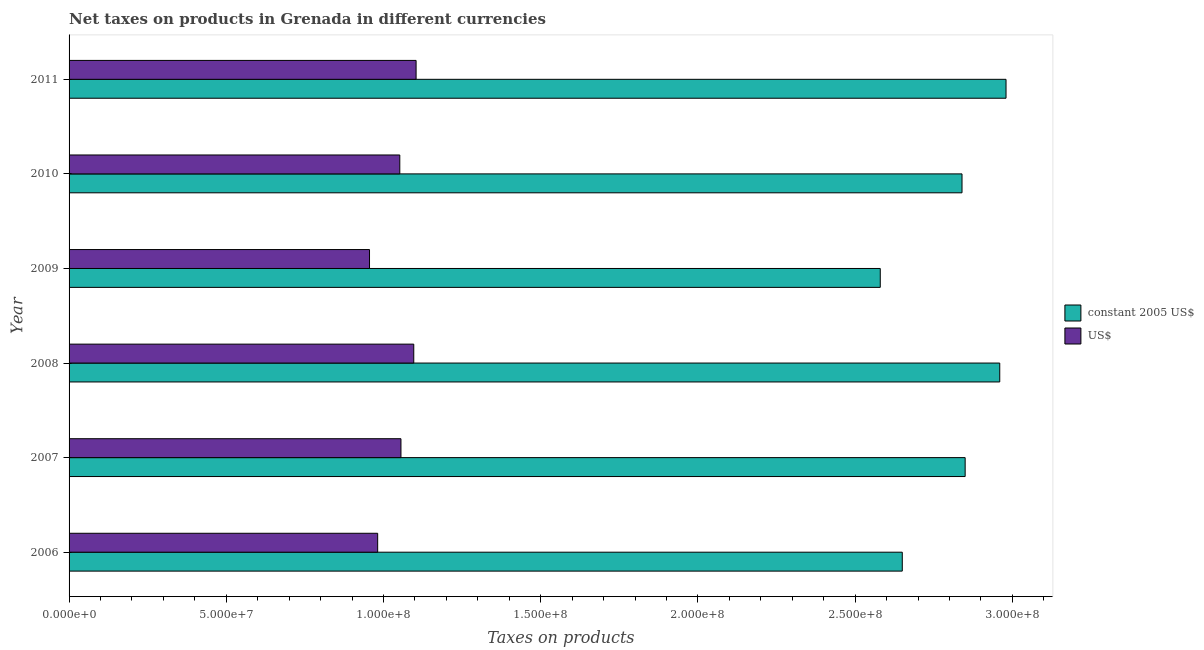How many groups of bars are there?
Provide a succinct answer. 6. Are the number of bars per tick equal to the number of legend labels?
Your answer should be very brief. Yes. How many bars are there on the 2nd tick from the bottom?
Keep it short and to the point. 2. What is the label of the 6th group of bars from the top?
Your response must be concise. 2006. In how many cases, is the number of bars for a given year not equal to the number of legend labels?
Provide a succinct answer. 0. What is the net taxes in constant 2005 us$ in 2009?
Your answer should be very brief. 2.58e+08. Across all years, what is the maximum net taxes in constant 2005 us$?
Offer a very short reply. 2.98e+08. Across all years, what is the minimum net taxes in us$?
Provide a short and direct response. 9.56e+07. In which year was the net taxes in constant 2005 us$ maximum?
Keep it short and to the point. 2011. In which year was the net taxes in constant 2005 us$ minimum?
Provide a short and direct response. 2009. What is the total net taxes in constant 2005 us$ in the graph?
Provide a short and direct response. 1.69e+09. What is the difference between the net taxes in us$ in 2006 and that in 2010?
Provide a succinct answer. -7.04e+06. What is the difference between the net taxes in us$ in 2008 and the net taxes in constant 2005 us$ in 2006?
Offer a very short reply. -1.55e+08. What is the average net taxes in us$ per year?
Provide a succinct answer. 1.04e+08. In the year 2007, what is the difference between the net taxes in us$ and net taxes in constant 2005 us$?
Your response must be concise. -1.79e+08. In how many years, is the net taxes in constant 2005 us$ greater than 40000000 units?
Your answer should be compact. 6. Is the difference between the net taxes in constant 2005 us$ in 2009 and 2011 greater than the difference between the net taxes in us$ in 2009 and 2011?
Provide a succinct answer. No. What is the difference between the highest and the second highest net taxes in us$?
Your answer should be very brief. 7.41e+05. What is the difference between the highest and the lowest net taxes in constant 2005 us$?
Ensure brevity in your answer.  4.00e+07. Is the sum of the net taxes in constant 2005 us$ in 2007 and 2009 greater than the maximum net taxes in us$ across all years?
Your answer should be very brief. Yes. What does the 1st bar from the top in 2011 represents?
Give a very brief answer. US$. What does the 2nd bar from the bottom in 2009 represents?
Provide a short and direct response. US$. How many bars are there?
Provide a short and direct response. 12. Are all the bars in the graph horizontal?
Give a very brief answer. Yes. How many years are there in the graph?
Your answer should be compact. 6. Are the values on the major ticks of X-axis written in scientific E-notation?
Offer a very short reply. Yes. Does the graph contain grids?
Your answer should be compact. No. Where does the legend appear in the graph?
Keep it short and to the point. Center right. How many legend labels are there?
Provide a short and direct response. 2. How are the legend labels stacked?
Your response must be concise. Vertical. What is the title of the graph?
Give a very brief answer. Net taxes on products in Grenada in different currencies. What is the label or title of the X-axis?
Provide a short and direct response. Taxes on products. What is the label or title of the Y-axis?
Keep it short and to the point. Year. What is the Taxes on products of constant 2005 US$ in 2006?
Give a very brief answer. 2.65e+08. What is the Taxes on products of US$ in 2006?
Give a very brief answer. 9.81e+07. What is the Taxes on products in constant 2005 US$ in 2007?
Keep it short and to the point. 2.85e+08. What is the Taxes on products in US$ in 2007?
Keep it short and to the point. 1.06e+08. What is the Taxes on products of constant 2005 US$ in 2008?
Provide a short and direct response. 2.96e+08. What is the Taxes on products of US$ in 2008?
Your answer should be compact. 1.10e+08. What is the Taxes on products in constant 2005 US$ in 2009?
Offer a terse response. 2.58e+08. What is the Taxes on products of US$ in 2009?
Provide a succinct answer. 9.56e+07. What is the Taxes on products of constant 2005 US$ in 2010?
Provide a succinct answer. 2.84e+08. What is the Taxes on products in US$ in 2010?
Provide a succinct answer. 1.05e+08. What is the Taxes on products of constant 2005 US$ in 2011?
Your answer should be compact. 2.98e+08. What is the Taxes on products of US$ in 2011?
Ensure brevity in your answer.  1.10e+08. Across all years, what is the maximum Taxes on products in constant 2005 US$?
Your answer should be very brief. 2.98e+08. Across all years, what is the maximum Taxes on products in US$?
Provide a short and direct response. 1.10e+08. Across all years, what is the minimum Taxes on products in constant 2005 US$?
Offer a very short reply. 2.58e+08. Across all years, what is the minimum Taxes on products in US$?
Give a very brief answer. 9.56e+07. What is the total Taxes on products in constant 2005 US$ in the graph?
Your answer should be compact. 1.69e+09. What is the total Taxes on products of US$ in the graph?
Offer a very short reply. 6.24e+08. What is the difference between the Taxes on products in constant 2005 US$ in 2006 and that in 2007?
Your answer should be very brief. -2.00e+07. What is the difference between the Taxes on products of US$ in 2006 and that in 2007?
Provide a succinct answer. -7.41e+06. What is the difference between the Taxes on products in constant 2005 US$ in 2006 and that in 2008?
Ensure brevity in your answer.  -3.10e+07. What is the difference between the Taxes on products in US$ in 2006 and that in 2008?
Your answer should be very brief. -1.15e+07. What is the difference between the Taxes on products of US$ in 2006 and that in 2009?
Your answer should be very brief. 2.59e+06. What is the difference between the Taxes on products of constant 2005 US$ in 2006 and that in 2010?
Your answer should be very brief. -1.90e+07. What is the difference between the Taxes on products of US$ in 2006 and that in 2010?
Provide a short and direct response. -7.04e+06. What is the difference between the Taxes on products of constant 2005 US$ in 2006 and that in 2011?
Your answer should be very brief. -3.30e+07. What is the difference between the Taxes on products in US$ in 2006 and that in 2011?
Your answer should be compact. -1.22e+07. What is the difference between the Taxes on products of constant 2005 US$ in 2007 and that in 2008?
Offer a terse response. -1.10e+07. What is the difference between the Taxes on products in US$ in 2007 and that in 2008?
Provide a short and direct response. -4.07e+06. What is the difference between the Taxes on products of constant 2005 US$ in 2007 and that in 2009?
Give a very brief answer. 2.70e+07. What is the difference between the Taxes on products in US$ in 2007 and that in 2009?
Your answer should be very brief. 1.00e+07. What is the difference between the Taxes on products of constant 2005 US$ in 2007 and that in 2010?
Offer a very short reply. 1.00e+06. What is the difference between the Taxes on products in US$ in 2007 and that in 2010?
Offer a terse response. 3.70e+05. What is the difference between the Taxes on products in constant 2005 US$ in 2007 and that in 2011?
Provide a succinct answer. -1.30e+07. What is the difference between the Taxes on products in US$ in 2007 and that in 2011?
Your answer should be compact. -4.81e+06. What is the difference between the Taxes on products of constant 2005 US$ in 2008 and that in 2009?
Give a very brief answer. 3.80e+07. What is the difference between the Taxes on products of US$ in 2008 and that in 2009?
Keep it short and to the point. 1.41e+07. What is the difference between the Taxes on products in US$ in 2008 and that in 2010?
Give a very brief answer. 4.44e+06. What is the difference between the Taxes on products in constant 2005 US$ in 2008 and that in 2011?
Your answer should be compact. -2.00e+06. What is the difference between the Taxes on products in US$ in 2008 and that in 2011?
Provide a short and direct response. -7.41e+05. What is the difference between the Taxes on products of constant 2005 US$ in 2009 and that in 2010?
Make the answer very short. -2.60e+07. What is the difference between the Taxes on products in US$ in 2009 and that in 2010?
Keep it short and to the point. -9.63e+06. What is the difference between the Taxes on products in constant 2005 US$ in 2009 and that in 2011?
Offer a very short reply. -4.00e+07. What is the difference between the Taxes on products of US$ in 2009 and that in 2011?
Provide a short and direct response. -1.48e+07. What is the difference between the Taxes on products in constant 2005 US$ in 2010 and that in 2011?
Keep it short and to the point. -1.40e+07. What is the difference between the Taxes on products of US$ in 2010 and that in 2011?
Ensure brevity in your answer.  -5.19e+06. What is the difference between the Taxes on products of constant 2005 US$ in 2006 and the Taxes on products of US$ in 2007?
Your answer should be compact. 1.59e+08. What is the difference between the Taxes on products of constant 2005 US$ in 2006 and the Taxes on products of US$ in 2008?
Your response must be concise. 1.55e+08. What is the difference between the Taxes on products in constant 2005 US$ in 2006 and the Taxes on products in US$ in 2009?
Ensure brevity in your answer.  1.69e+08. What is the difference between the Taxes on products of constant 2005 US$ in 2006 and the Taxes on products of US$ in 2010?
Offer a very short reply. 1.60e+08. What is the difference between the Taxes on products of constant 2005 US$ in 2006 and the Taxes on products of US$ in 2011?
Your answer should be very brief. 1.55e+08. What is the difference between the Taxes on products of constant 2005 US$ in 2007 and the Taxes on products of US$ in 2008?
Your answer should be very brief. 1.75e+08. What is the difference between the Taxes on products of constant 2005 US$ in 2007 and the Taxes on products of US$ in 2009?
Offer a terse response. 1.89e+08. What is the difference between the Taxes on products of constant 2005 US$ in 2007 and the Taxes on products of US$ in 2010?
Make the answer very short. 1.80e+08. What is the difference between the Taxes on products in constant 2005 US$ in 2007 and the Taxes on products in US$ in 2011?
Make the answer very short. 1.75e+08. What is the difference between the Taxes on products in constant 2005 US$ in 2008 and the Taxes on products in US$ in 2009?
Give a very brief answer. 2.00e+08. What is the difference between the Taxes on products of constant 2005 US$ in 2008 and the Taxes on products of US$ in 2010?
Your response must be concise. 1.91e+08. What is the difference between the Taxes on products of constant 2005 US$ in 2008 and the Taxes on products of US$ in 2011?
Ensure brevity in your answer.  1.86e+08. What is the difference between the Taxes on products of constant 2005 US$ in 2009 and the Taxes on products of US$ in 2010?
Your answer should be compact. 1.53e+08. What is the difference between the Taxes on products of constant 2005 US$ in 2009 and the Taxes on products of US$ in 2011?
Make the answer very short. 1.48e+08. What is the difference between the Taxes on products of constant 2005 US$ in 2010 and the Taxes on products of US$ in 2011?
Offer a very short reply. 1.74e+08. What is the average Taxes on products in constant 2005 US$ per year?
Make the answer very short. 2.81e+08. What is the average Taxes on products of US$ per year?
Provide a short and direct response. 1.04e+08. In the year 2006, what is the difference between the Taxes on products in constant 2005 US$ and Taxes on products in US$?
Offer a terse response. 1.67e+08. In the year 2007, what is the difference between the Taxes on products of constant 2005 US$ and Taxes on products of US$?
Make the answer very short. 1.79e+08. In the year 2008, what is the difference between the Taxes on products in constant 2005 US$ and Taxes on products in US$?
Provide a short and direct response. 1.86e+08. In the year 2009, what is the difference between the Taxes on products in constant 2005 US$ and Taxes on products in US$?
Give a very brief answer. 1.62e+08. In the year 2010, what is the difference between the Taxes on products in constant 2005 US$ and Taxes on products in US$?
Offer a very short reply. 1.79e+08. In the year 2011, what is the difference between the Taxes on products of constant 2005 US$ and Taxes on products of US$?
Your answer should be very brief. 1.88e+08. What is the ratio of the Taxes on products of constant 2005 US$ in 2006 to that in 2007?
Provide a short and direct response. 0.93. What is the ratio of the Taxes on products in US$ in 2006 to that in 2007?
Offer a terse response. 0.93. What is the ratio of the Taxes on products of constant 2005 US$ in 2006 to that in 2008?
Ensure brevity in your answer.  0.9. What is the ratio of the Taxes on products of US$ in 2006 to that in 2008?
Offer a very short reply. 0.9. What is the ratio of the Taxes on products in constant 2005 US$ in 2006 to that in 2009?
Ensure brevity in your answer.  1.03. What is the ratio of the Taxes on products in US$ in 2006 to that in 2009?
Ensure brevity in your answer.  1.03. What is the ratio of the Taxes on products of constant 2005 US$ in 2006 to that in 2010?
Provide a succinct answer. 0.93. What is the ratio of the Taxes on products in US$ in 2006 to that in 2010?
Make the answer very short. 0.93. What is the ratio of the Taxes on products of constant 2005 US$ in 2006 to that in 2011?
Your answer should be compact. 0.89. What is the ratio of the Taxes on products in US$ in 2006 to that in 2011?
Ensure brevity in your answer.  0.89. What is the ratio of the Taxes on products in constant 2005 US$ in 2007 to that in 2008?
Give a very brief answer. 0.96. What is the ratio of the Taxes on products in US$ in 2007 to that in 2008?
Offer a terse response. 0.96. What is the ratio of the Taxes on products of constant 2005 US$ in 2007 to that in 2009?
Your response must be concise. 1.1. What is the ratio of the Taxes on products of US$ in 2007 to that in 2009?
Your response must be concise. 1.1. What is the ratio of the Taxes on products of constant 2005 US$ in 2007 to that in 2010?
Provide a short and direct response. 1. What is the ratio of the Taxes on products of US$ in 2007 to that in 2010?
Your answer should be very brief. 1. What is the ratio of the Taxes on products of constant 2005 US$ in 2007 to that in 2011?
Your answer should be compact. 0.96. What is the ratio of the Taxes on products in US$ in 2007 to that in 2011?
Ensure brevity in your answer.  0.96. What is the ratio of the Taxes on products of constant 2005 US$ in 2008 to that in 2009?
Ensure brevity in your answer.  1.15. What is the ratio of the Taxes on products in US$ in 2008 to that in 2009?
Make the answer very short. 1.15. What is the ratio of the Taxes on products of constant 2005 US$ in 2008 to that in 2010?
Provide a short and direct response. 1.04. What is the ratio of the Taxes on products of US$ in 2008 to that in 2010?
Make the answer very short. 1.04. What is the ratio of the Taxes on products of constant 2005 US$ in 2009 to that in 2010?
Keep it short and to the point. 0.91. What is the ratio of the Taxes on products in US$ in 2009 to that in 2010?
Provide a short and direct response. 0.91. What is the ratio of the Taxes on products of constant 2005 US$ in 2009 to that in 2011?
Offer a very short reply. 0.87. What is the ratio of the Taxes on products in US$ in 2009 to that in 2011?
Your response must be concise. 0.87. What is the ratio of the Taxes on products of constant 2005 US$ in 2010 to that in 2011?
Ensure brevity in your answer.  0.95. What is the ratio of the Taxes on products in US$ in 2010 to that in 2011?
Give a very brief answer. 0.95. What is the difference between the highest and the second highest Taxes on products of US$?
Give a very brief answer. 7.41e+05. What is the difference between the highest and the lowest Taxes on products in constant 2005 US$?
Provide a succinct answer. 4.00e+07. What is the difference between the highest and the lowest Taxes on products of US$?
Keep it short and to the point. 1.48e+07. 